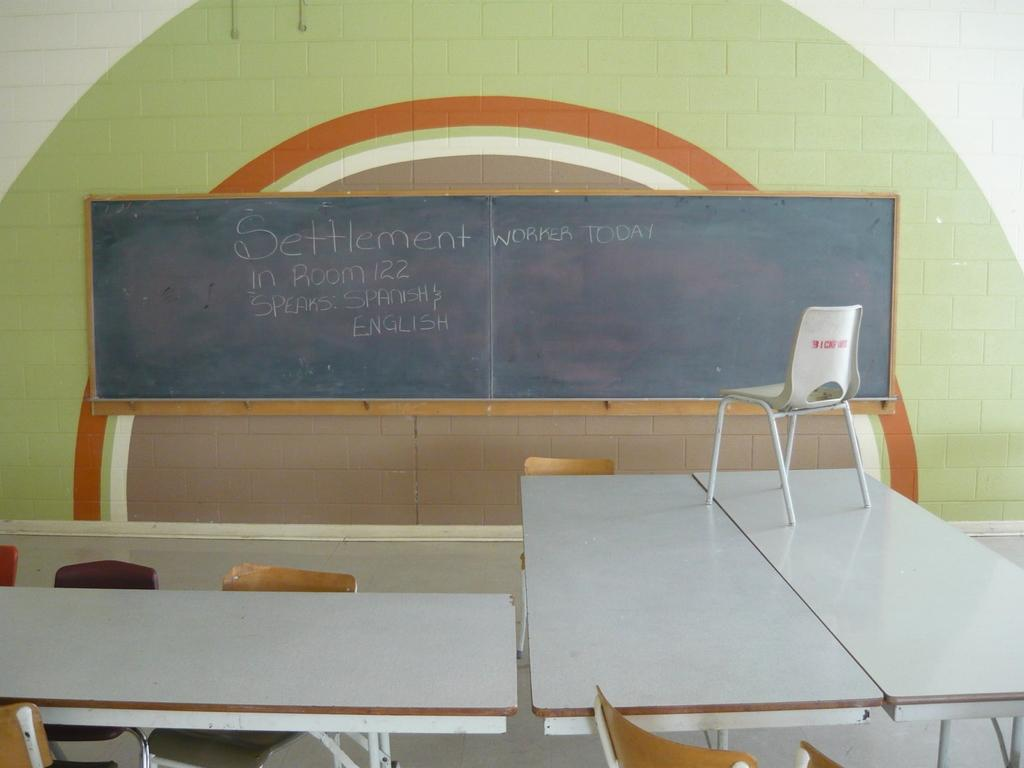<image>
Provide a brief description of the given image. A chalkboard has the text "Settlement worker today in room 122 speaks: Spanish & English" 